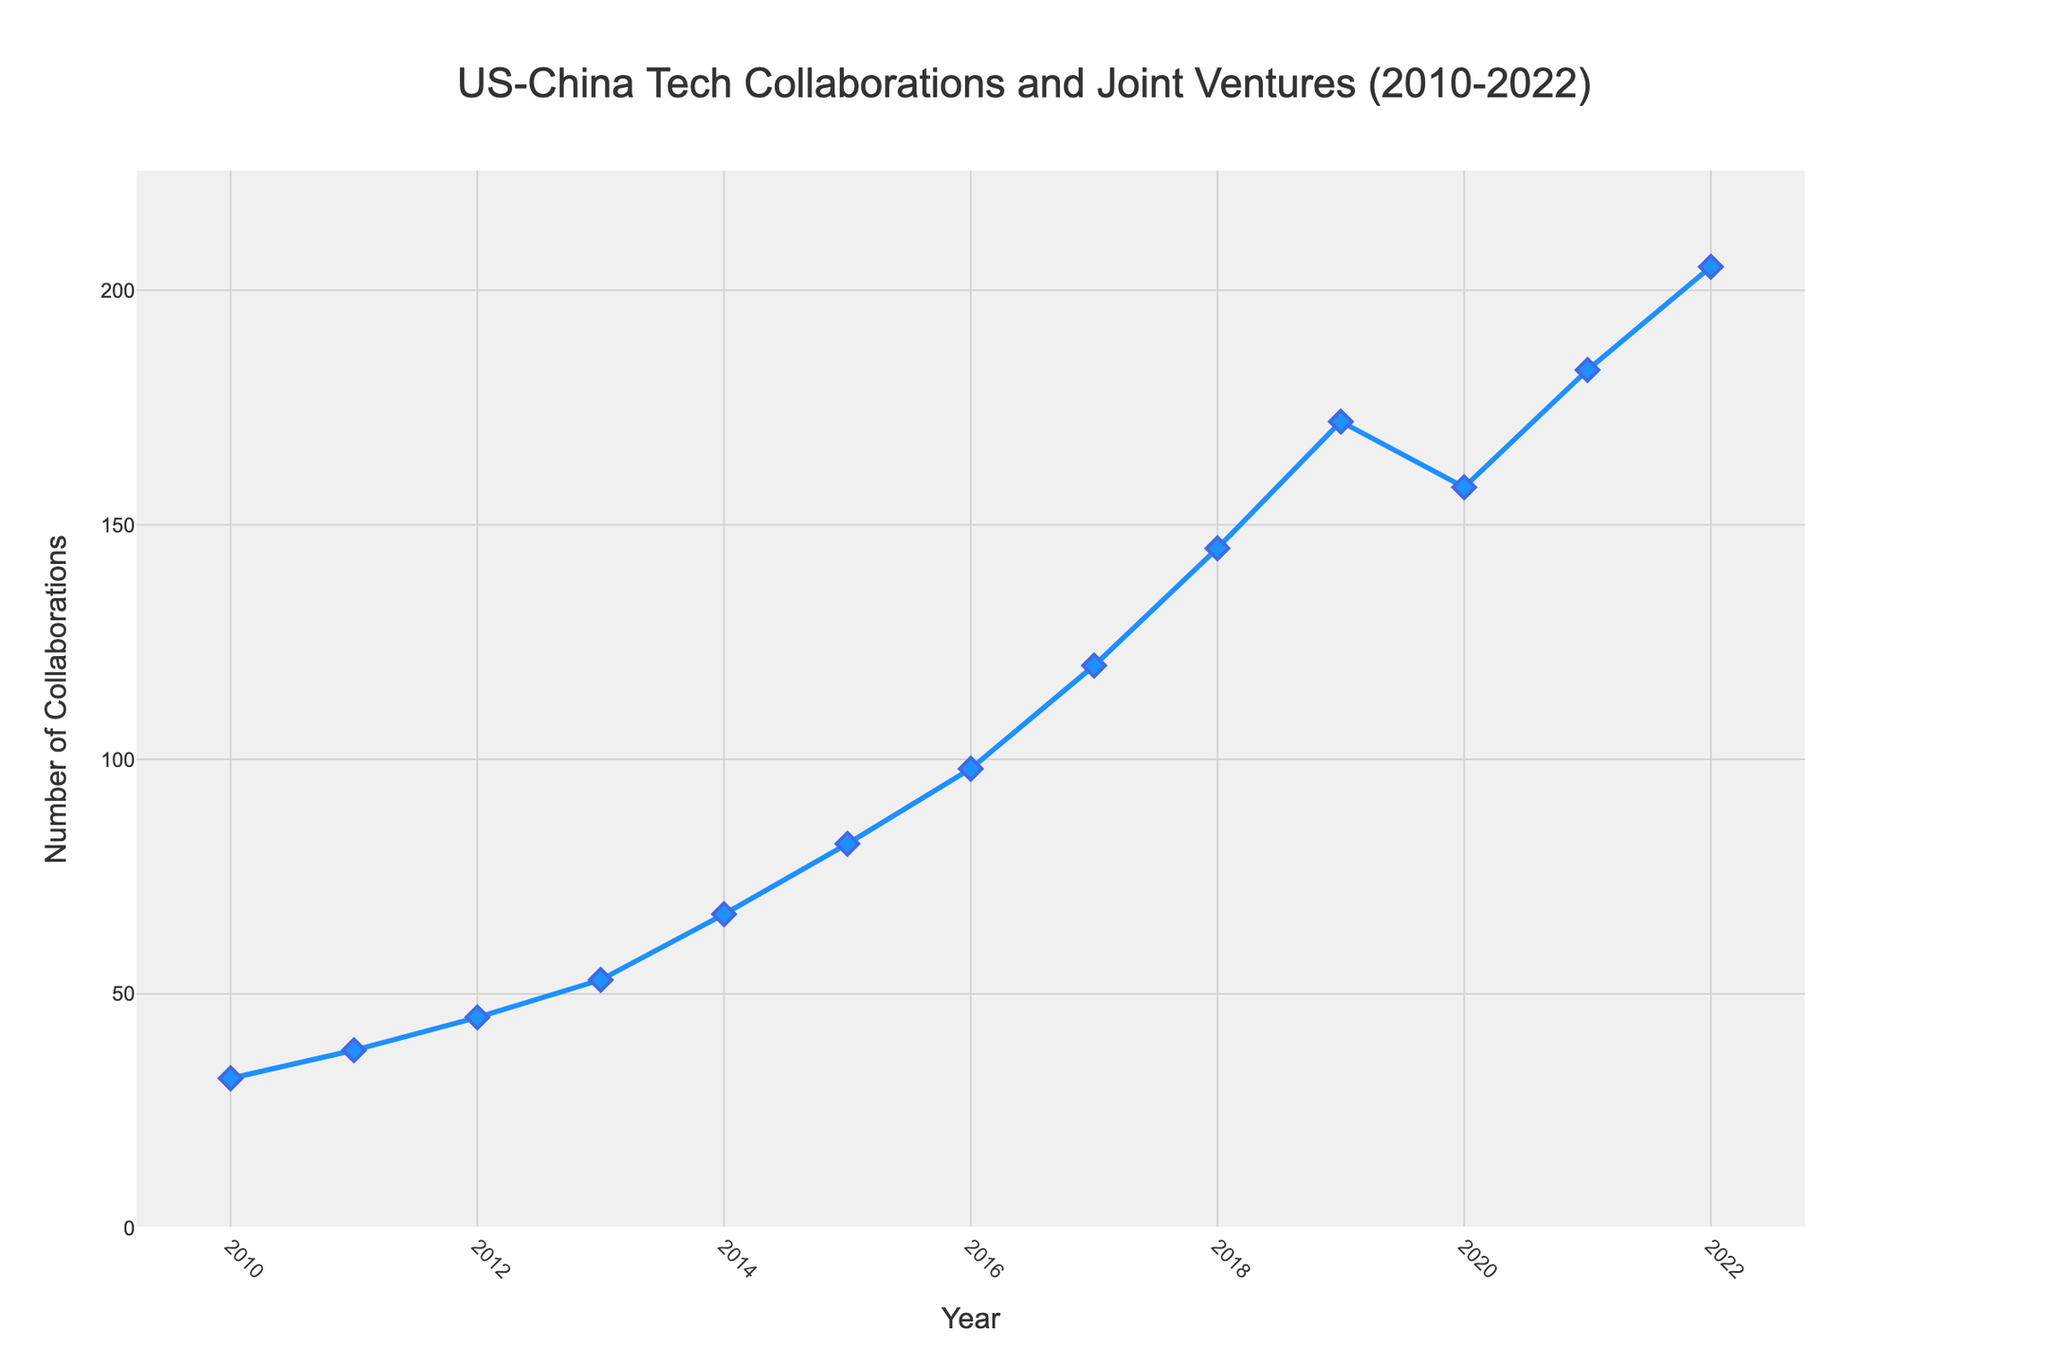How many total US-China tech collaborations and joint ventures were there in the years 2010, 2011, and 2012 combined? Sum the number of collaborations from 2010, 2011, and 2012: 32 + 38 + 45 = 115
Answer: 115 What is the average number of US-China tech collaborations and joint ventures from 2010 to 2012? First, sum the values from 2010 to 2012: 32 + 38 + 45 = 115. Then divide this by 3 (the number of years): 115 / 3 ≈ 38.33
Answer: 38.33 Between which years did the number of US-China tech collaborations and joint ventures increase the most? Observe the differences in collaborations between consecutive years. The maximum increase is between 2013 and 2014, where the count goes from 53 to 67 (difference of 14).
Answer: 2013-2014 How did the number of collaborations change between 2019 and 2020? The count decreased from 172 in 2019 to 158 in 2020. The change is calculated as 158 - 172 = -14.
Answer: -14 In which year did the number of US-China tech collaborations and joint ventures first exceed 100? By inspecting the figure, the number first exceeds 100 in 2017 with a count of 120.
Answer: 2017 What is the trend in US-China tech collaborations from 2010 to 2022? The general trend shows a steady increase from 2010 to 2022 with a small dip in 2020. Overall, the count rises from 32 to 205.
Answer: Steady increase with a small dip in 2020 How many more collaborations were there in 2022 compared to 2010? Subtract the value in 2010 from the value in 2022: 205 - 32 = 173.
Answer: 173 Which year had fewer collaborations, 2016 or 2017? From the plot, 2016 had 98 collaborations, and 2017 had 120, so 2016 had fewer.
Answer: 2016 What is the median number of US-China tech collaborations and joint ventures over the period 2010 to 2022? To find the median, sort the values: [32, 38, 45, 53, 67, 82, 98, 120, 145, 158, 172, 183, 205]. The middle value in this sorted list is 98.
Answer: 98 Which year had the largest decrease in the number of US-China tech collaborations and joint ventures compared to the previous year? Compare each year's data to the previous year's data to find the largest decrease. The largest decrease is from 2019 to 2020, where it fell from 172 to 158 (14 units decrease).
Answer: 2019-2020 